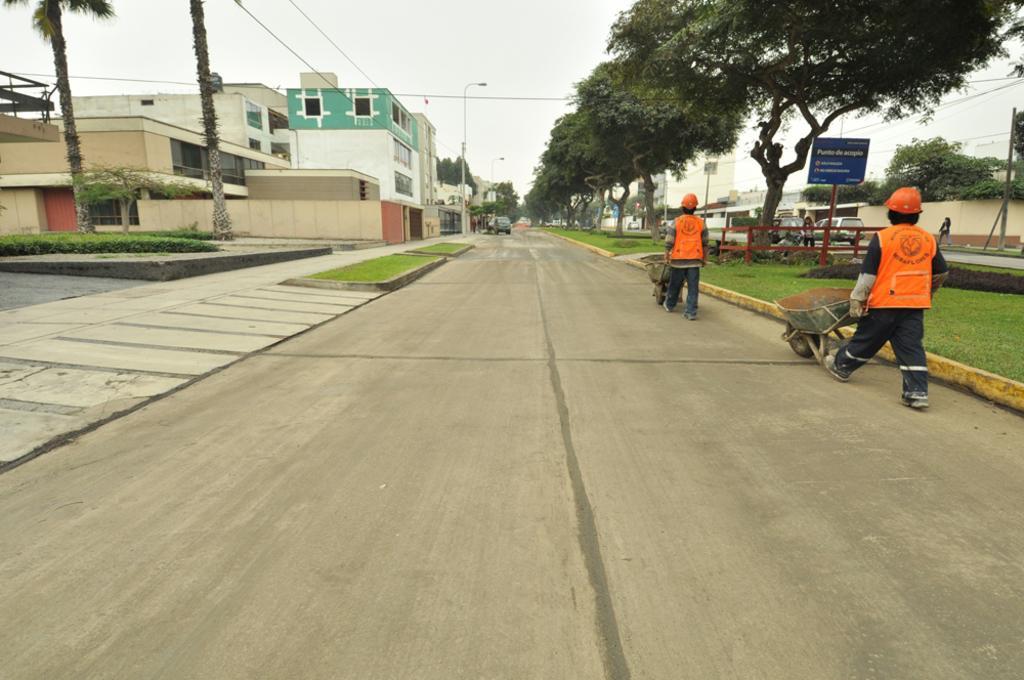In one or two sentences, can you explain what this image depicts? In this picture we can see carts, two people wore helmets and walking on the road and in front of them we can see the grass, name board, vehicles, trees, buildings, poles and some objects and in the background we can see the sky. 